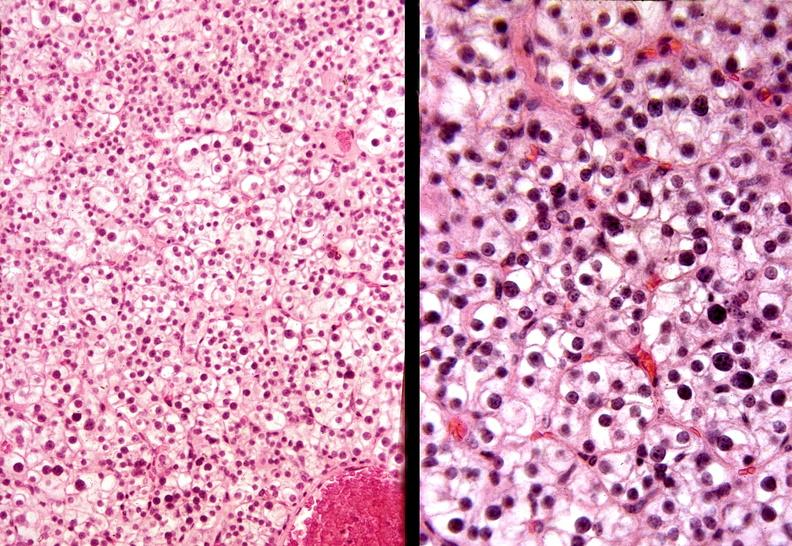s hemorrhage in newborn present?
Answer the question using a single word or phrase. No 